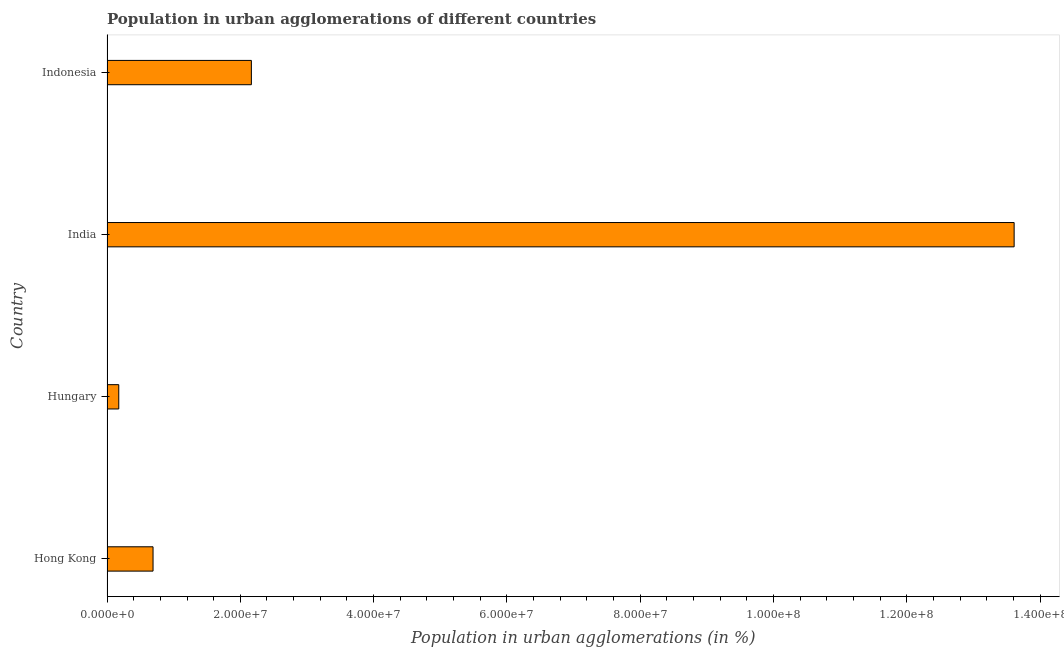Does the graph contain any zero values?
Offer a very short reply. No. What is the title of the graph?
Offer a very short reply. Population in urban agglomerations of different countries. What is the label or title of the X-axis?
Give a very brief answer. Population in urban agglomerations (in %). What is the population in urban agglomerations in Indonesia?
Offer a terse response. 2.17e+07. Across all countries, what is the maximum population in urban agglomerations?
Your response must be concise. 1.36e+08. Across all countries, what is the minimum population in urban agglomerations?
Your answer should be very brief. 1.76e+06. In which country was the population in urban agglomerations minimum?
Your response must be concise. Hungary. What is the sum of the population in urban agglomerations?
Make the answer very short. 1.66e+08. What is the difference between the population in urban agglomerations in India and Indonesia?
Keep it short and to the point. 1.14e+08. What is the average population in urban agglomerations per country?
Your response must be concise. 4.16e+07. What is the median population in urban agglomerations?
Keep it short and to the point. 1.43e+07. In how many countries, is the population in urban agglomerations greater than 116000000 %?
Keep it short and to the point. 1. What is the ratio of the population in urban agglomerations in Hungary to that in Indonesia?
Provide a short and direct response. 0.08. Is the population in urban agglomerations in India less than that in Indonesia?
Offer a very short reply. No. What is the difference between the highest and the second highest population in urban agglomerations?
Keep it short and to the point. 1.14e+08. Is the sum of the population in urban agglomerations in Hungary and Indonesia greater than the maximum population in urban agglomerations across all countries?
Offer a terse response. No. What is the difference between the highest and the lowest population in urban agglomerations?
Provide a succinct answer. 1.34e+08. Are all the bars in the graph horizontal?
Give a very brief answer. Yes. Are the values on the major ticks of X-axis written in scientific E-notation?
Ensure brevity in your answer.  Yes. What is the Population in urban agglomerations (in %) of Hong Kong?
Provide a short and direct response. 6.91e+06. What is the Population in urban agglomerations (in %) of Hungary?
Make the answer very short. 1.76e+06. What is the Population in urban agglomerations (in %) of India?
Provide a succinct answer. 1.36e+08. What is the Population in urban agglomerations (in %) of Indonesia?
Give a very brief answer. 2.17e+07. What is the difference between the Population in urban agglomerations (in %) in Hong Kong and Hungary?
Ensure brevity in your answer.  5.14e+06. What is the difference between the Population in urban agglomerations (in %) in Hong Kong and India?
Ensure brevity in your answer.  -1.29e+08. What is the difference between the Population in urban agglomerations (in %) in Hong Kong and Indonesia?
Offer a very short reply. -1.48e+07. What is the difference between the Population in urban agglomerations (in %) in Hungary and India?
Your answer should be very brief. -1.34e+08. What is the difference between the Population in urban agglomerations (in %) in Hungary and Indonesia?
Offer a very short reply. -1.99e+07. What is the difference between the Population in urban agglomerations (in %) in India and Indonesia?
Your response must be concise. 1.14e+08. What is the ratio of the Population in urban agglomerations (in %) in Hong Kong to that in Hungary?
Keep it short and to the point. 3.91. What is the ratio of the Population in urban agglomerations (in %) in Hong Kong to that in India?
Provide a short and direct response. 0.05. What is the ratio of the Population in urban agglomerations (in %) in Hong Kong to that in Indonesia?
Give a very brief answer. 0.32. What is the ratio of the Population in urban agglomerations (in %) in Hungary to that in India?
Keep it short and to the point. 0.01. What is the ratio of the Population in urban agglomerations (in %) in Hungary to that in Indonesia?
Your response must be concise. 0.08. What is the ratio of the Population in urban agglomerations (in %) in India to that in Indonesia?
Provide a succinct answer. 6.28. 